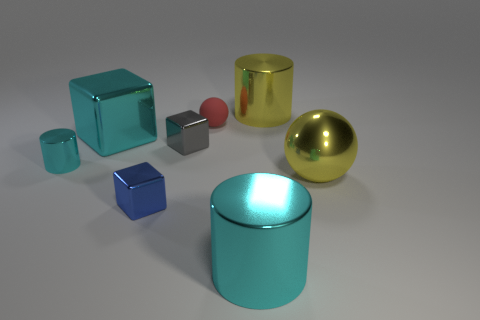Subtract all cyan blocks. How many blocks are left? 2 Subtract 1 cylinders. How many cylinders are left? 2 Add 2 small metallic objects. How many objects exist? 10 Subtract all cylinders. How many objects are left? 5 Subtract 1 cyan cubes. How many objects are left? 7 Subtract all metal things. Subtract all small cyan cylinders. How many objects are left? 0 Add 5 large yellow metal objects. How many large yellow metal objects are left? 7 Add 3 large cylinders. How many large cylinders exist? 5 